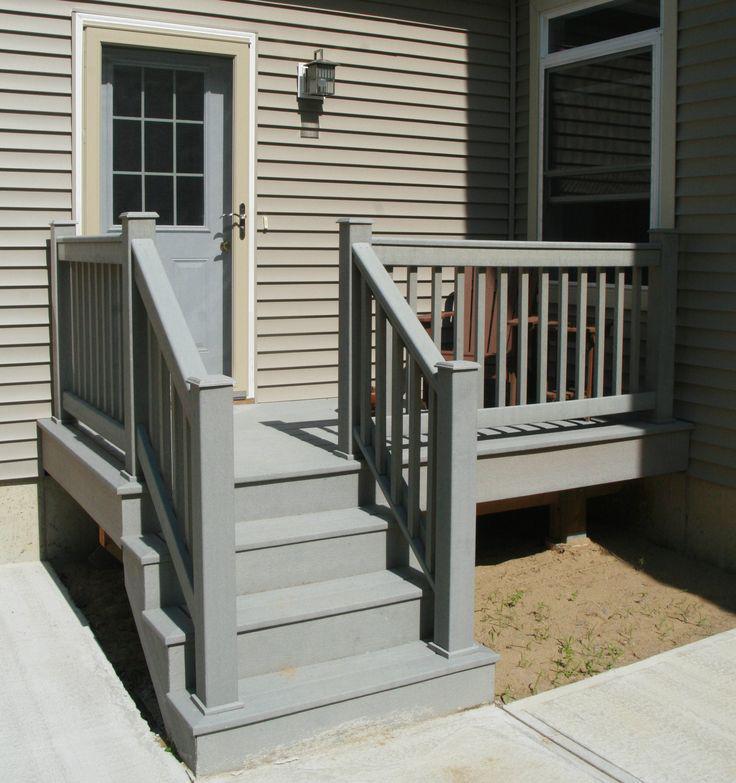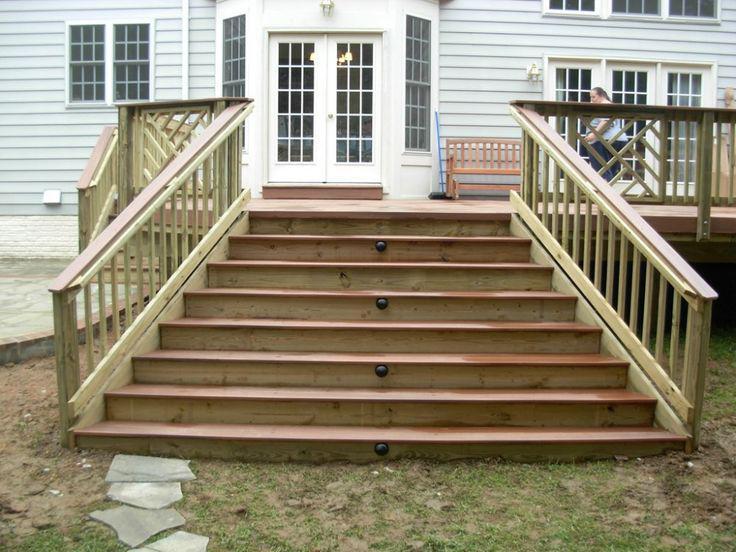The first image is the image on the left, the second image is the image on the right. For the images shown, is this caption "In one image, a wooden deck with ballustrade and set of stairs is outside the double doors of a house." true? Answer yes or no. Yes. The first image is the image on the left, the second image is the image on the right. Analyze the images presented: Is the assertion "The left image contains one human doing carpentry." valid? Answer yes or no. No. 